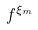Convert formula to latex. <formula><loc_0><loc_0><loc_500><loc_500>f ^ { \xi _ { m } }</formula> 